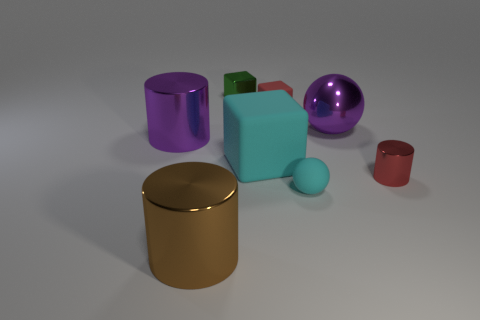The tiny matte sphere has what color?
Your answer should be compact. Cyan. Do the metal ball and the large cylinder behind the red shiny cylinder have the same color?
Offer a very short reply. Yes. Are there any large metal cylinders of the same color as the big rubber object?
Your response must be concise. No. There is a thing that is the same color as the big rubber block; what size is it?
Your answer should be very brief. Small. Do the tiny metal cylinder and the tiny sphere have the same color?
Your answer should be compact. No. Are there fewer purple matte blocks than green blocks?
Keep it short and to the point. Yes. What size is the cylinder that is both behind the small cyan ball and to the left of the big cyan thing?
Provide a short and direct response. Large. Is the red cylinder the same size as the brown metal thing?
Give a very brief answer. No. There is a metal thing that is behind the red matte cube; does it have the same color as the small matte cube?
Your answer should be compact. No. What number of big purple cylinders are behind the cyan block?
Keep it short and to the point. 1. 